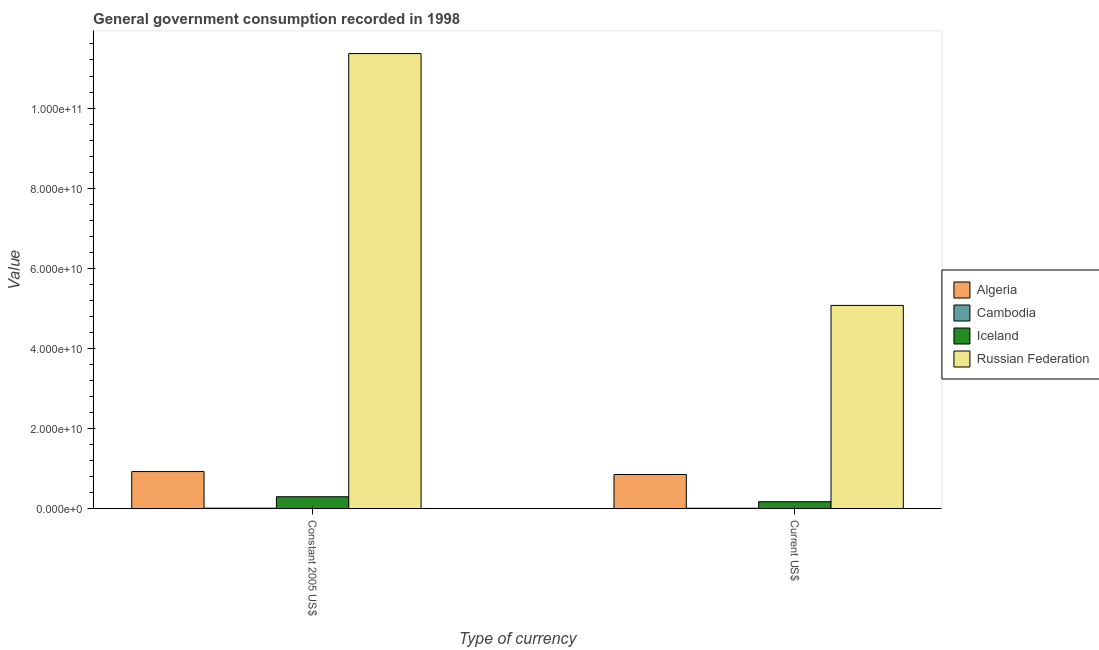How many different coloured bars are there?
Provide a succinct answer. 4. Are the number of bars per tick equal to the number of legend labels?
Your answer should be very brief. Yes. Are the number of bars on each tick of the X-axis equal?
Offer a very short reply. Yes. How many bars are there on the 1st tick from the right?
Provide a succinct answer. 4. What is the label of the 1st group of bars from the left?
Provide a succinct answer. Constant 2005 US$. What is the value consumed in constant 2005 us$ in Russian Federation?
Make the answer very short. 1.14e+11. Across all countries, what is the maximum value consumed in constant 2005 us$?
Give a very brief answer. 1.14e+11. Across all countries, what is the minimum value consumed in current us$?
Offer a very short reply. 1.50e+08. In which country was the value consumed in constant 2005 us$ maximum?
Give a very brief answer. Russian Federation. In which country was the value consumed in constant 2005 us$ minimum?
Your answer should be very brief. Cambodia. What is the total value consumed in current us$ in the graph?
Your answer should be very brief. 6.13e+1. What is the difference between the value consumed in current us$ in Cambodia and that in Russian Federation?
Your response must be concise. -5.06e+1. What is the difference between the value consumed in constant 2005 us$ in Cambodia and the value consumed in current us$ in Iceland?
Your answer should be compact. -1.62e+09. What is the average value consumed in current us$ per country?
Your answer should be very brief. 1.53e+1. What is the difference between the value consumed in constant 2005 us$ and value consumed in current us$ in Iceland?
Offer a terse response. 1.24e+09. In how many countries, is the value consumed in current us$ greater than 44000000000 ?
Ensure brevity in your answer.  1. What is the ratio of the value consumed in current us$ in Russian Federation to that in Iceland?
Ensure brevity in your answer.  28.44. In how many countries, is the value consumed in current us$ greater than the average value consumed in current us$ taken over all countries?
Provide a succinct answer. 1. What does the 3rd bar from the right in Current US$ represents?
Ensure brevity in your answer.  Cambodia. How many countries are there in the graph?
Provide a succinct answer. 4. Does the graph contain any zero values?
Offer a very short reply. No. What is the title of the graph?
Make the answer very short. General government consumption recorded in 1998. What is the label or title of the X-axis?
Your answer should be compact. Type of currency. What is the label or title of the Y-axis?
Offer a very short reply. Value. What is the Value in Algeria in Constant 2005 US$?
Your answer should be very brief. 9.30e+09. What is the Value in Cambodia in Constant 2005 US$?
Offer a very short reply. 1.62e+08. What is the Value in Iceland in Constant 2005 US$?
Your response must be concise. 3.02e+09. What is the Value in Russian Federation in Constant 2005 US$?
Offer a very short reply. 1.14e+11. What is the Value of Algeria in Current US$?
Ensure brevity in your answer.  8.57e+09. What is the Value in Cambodia in Current US$?
Offer a very short reply. 1.50e+08. What is the Value of Iceland in Current US$?
Your answer should be compact. 1.78e+09. What is the Value of Russian Federation in Current US$?
Make the answer very short. 5.08e+1. Across all Type of currency, what is the maximum Value in Algeria?
Make the answer very short. 9.30e+09. Across all Type of currency, what is the maximum Value in Cambodia?
Provide a short and direct response. 1.62e+08. Across all Type of currency, what is the maximum Value of Iceland?
Offer a very short reply. 3.02e+09. Across all Type of currency, what is the maximum Value in Russian Federation?
Your answer should be compact. 1.14e+11. Across all Type of currency, what is the minimum Value of Algeria?
Offer a terse response. 8.57e+09. Across all Type of currency, what is the minimum Value of Cambodia?
Give a very brief answer. 1.50e+08. Across all Type of currency, what is the minimum Value of Iceland?
Keep it short and to the point. 1.78e+09. Across all Type of currency, what is the minimum Value in Russian Federation?
Your answer should be very brief. 5.08e+1. What is the total Value in Algeria in the graph?
Make the answer very short. 1.79e+1. What is the total Value in Cambodia in the graph?
Make the answer very short. 3.12e+08. What is the total Value in Iceland in the graph?
Your response must be concise. 4.80e+09. What is the total Value of Russian Federation in the graph?
Make the answer very short. 1.64e+11. What is the difference between the Value of Algeria in Constant 2005 US$ and that in Current US$?
Offer a terse response. 7.28e+08. What is the difference between the Value of Cambodia in Constant 2005 US$ and that in Current US$?
Offer a very short reply. 1.23e+07. What is the difference between the Value of Iceland in Constant 2005 US$ and that in Current US$?
Ensure brevity in your answer.  1.24e+09. What is the difference between the Value in Russian Federation in Constant 2005 US$ and that in Current US$?
Make the answer very short. 6.28e+1. What is the difference between the Value of Algeria in Constant 2005 US$ and the Value of Cambodia in Current US$?
Make the answer very short. 9.15e+09. What is the difference between the Value of Algeria in Constant 2005 US$ and the Value of Iceland in Current US$?
Offer a very short reply. 7.52e+09. What is the difference between the Value in Algeria in Constant 2005 US$ and the Value in Russian Federation in Current US$?
Your answer should be very brief. -4.15e+1. What is the difference between the Value of Cambodia in Constant 2005 US$ and the Value of Iceland in Current US$?
Provide a short and direct response. -1.62e+09. What is the difference between the Value in Cambodia in Constant 2005 US$ and the Value in Russian Federation in Current US$?
Offer a very short reply. -5.06e+1. What is the difference between the Value in Iceland in Constant 2005 US$ and the Value in Russian Federation in Current US$?
Your response must be concise. -4.77e+1. What is the average Value in Algeria per Type of currency?
Offer a very short reply. 8.94e+09. What is the average Value in Cambodia per Type of currency?
Provide a succinct answer. 1.56e+08. What is the average Value in Iceland per Type of currency?
Give a very brief answer. 2.40e+09. What is the average Value of Russian Federation per Type of currency?
Your answer should be compact. 8.22e+1. What is the difference between the Value of Algeria and Value of Cambodia in Constant 2005 US$?
Your answer should be compact. 9.14e+09. What is the difference between the Value in Algeria and Value in Iceland in Constant 2005 US$?
Give a very brief answer. 6.28e+09. What is the difference between the Value of Algeria and Value of Russian Federation in Constant 2005 US$?
Your response must be concise. -1.04e+11. What is the difference between the Value in Cambodia and Value in Iceland in Constant 2005 US$?
Keep it short and to the point. -2.86e+09. What is the difference between the Value of Cambodia and Value of Russian Federation in Constant 2005 US$?
Offer a very short reply. -1.13e+11. What is the difference between the Value of Iceland and Value of Russian Federation in Constant 2005 US$?
Give a very brief answer. -1.11e+11. What is the difference between the Value of Algeria and Value of Cambodia in Current US$?
Provide a succinct answer. 8.42e+09. What is the difference between the Value of Algeria and Value of Iceland in Current US$?
Provide a succinct answer. 6.79e+09. What is the difference between the Value in Algeria and Value in Russian Federation in Current US$?
Offer a very short reply. -4.22e+1. What is the difference between the Value in Cambodia and Value in Iceland in Current US$?
Ensure brevity in your answer.  -1.63e+09. What is the difference between the Value in Cambodia and Value in Russian Federation in Current US$?
Offer a very short reply. -5.06e+1. What is the difference between the Value in Iceland and Value in Russian Federation in Current US$?
Provide a short and direct response. -4.90e+1. What is the ratio of the Value of Algeria in Constant 2005 US$ to that in Current US$?
Your answer should be compact. 1.08. What is the ratio of the Value of Cambodia in Constant 2005 US$ to that in Current US$?
Your response must be concise. 1.08. What is the ratio of the Value in Iceland in Constant 2005 US$ to that in Current US$?
Offer a terse response. 1.69. What is the ratio of the Value in Russian Federation in Constant 2005 US$ to that in Current US$?
Ensure brevity in your answer.  2.24. What is the difference between the highest and the second highest Value in Algeria?
Your answer should be very brief. 7.28e+08. What is the difference between the highest and the second highest Value in Cambodia?
Provide a succinct answer. 1.23e+07. What is the difference between the highest and the second highest Value in Iceland?
Provide a succinct answer. 1.24e+09. What is the difference between the highest and the second highest Value in Russian Federation?
Your answer should be very brief. 6.28e+1. What is the difference between the highest and the lowest Value of Algeria?
Provide a short and direct response. 7.28e+08. What is the difference between the highest and the lowest Value in Cambodia?
Provide a short and direct response. 1.23e+07. What is the difference between the highest and the lowest Value in Iceland?
Offer a very short reply. 1.24e+09. What is the difference between the highest and the lowest Value in Russian Federation?
Offer a terse response. 6.28e+1. 